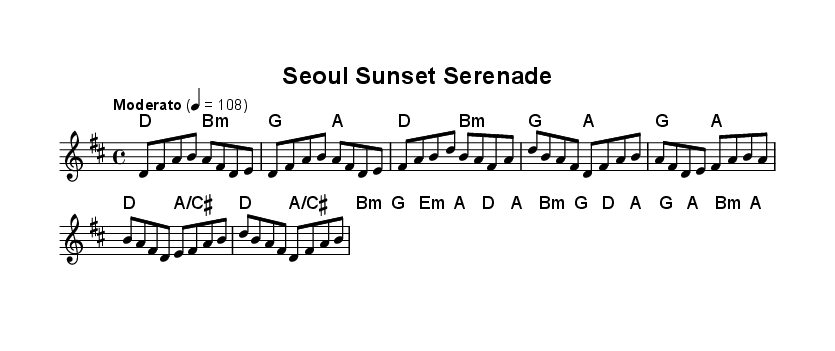What is the key signature of this music? The key signature in the music indicates D major, which is shown by the two sharps (F# and C#) present in the example.
Answer: D major What is the time signature of this music? The time signature displayed in the music is 4/4, which means there are four beats in each measure and the quarter note gets one beat.
Answer: 4/4 What is the tempo marking for this piece? The tempo marking indicates "Moderato," which suggests a moderate tempo, usually around 108 beats per minute as indicated by the number below.
Answer: Moderato How many measures are present in the melody section? Counting from the start of the melody through to the end, there are a total of 10 measures in the provided melody portion.
Answer: 10 What chords are used in the chorus section? In the chorus, the chords displayed are D major, A/C#, B minor, and G major, which are voiced in the provided harmonies.
Answer: D, A/C#, B minor, G How does the bridge section contrast with the verse section? The bridge section introduces B minor as a new harmony alongside G major and features different melodic content that creates a distinct contrast with the more straightforward progression in the verse.
Answer: Contrast in harmony and melody Which traditional Korean instrument could be represented in the compositions of this style? Traditional instruments like the gayageum or daegeum are often integrated into folk fusion, but specific indications are not shown in the current sheet but are common in the genre.
Answer: Gayageum or daegeum 